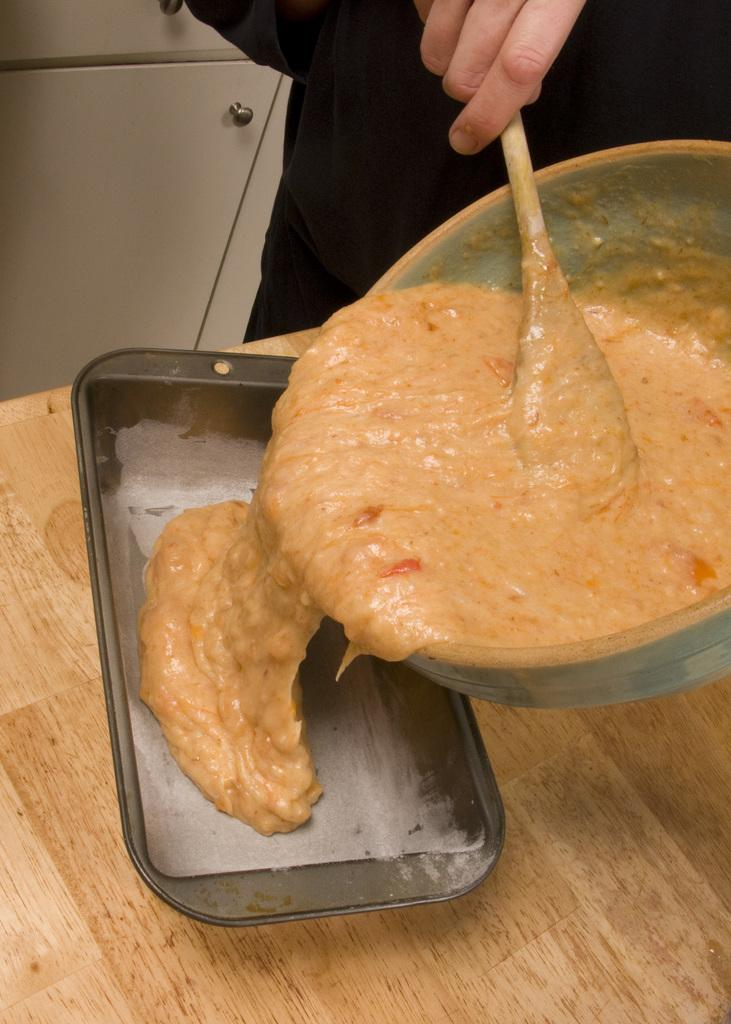What is the person in the image doing? The person is standing and holding a spoon in the image. What action is the person performing with the spoon? The person is pouring a food item into a tray. Where is the tray located? The tray is on a table. What can be seen in the background of the image? There is a cupboard in the background of the image. Can you hear the person coughing in the image? There is no indication of sound or a cough in the image, as it is a still photograph. 